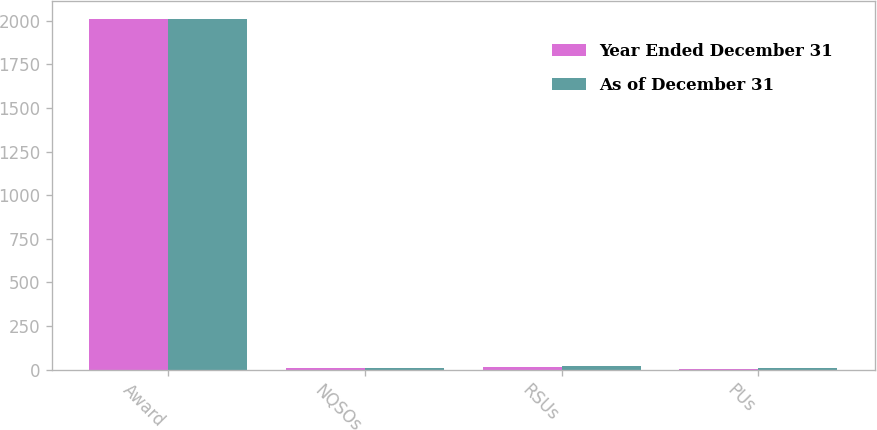<chart> <loc_0><loc_0><loc_500><loc_500><stacked_bar_chart><ecel><fcel>Award<fcel>NQSOs<fcel>RSUs<fcel>PUs<nl><fcel>Year Ended December 31<fcel>2010<fcel>8<fcel>15<fcel>6<nl><fcel>As of December 31<fcel>2010<fcel>7<fcel>22<fcel>8<nl></chart> 